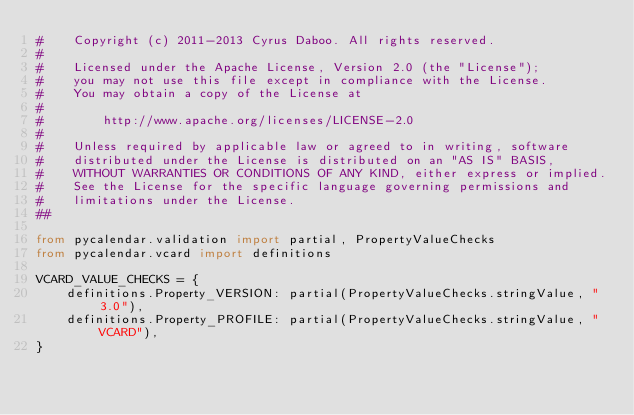Convert code to text. <code><loc_0><loc_0><loc_500><loc_500><_Python_>#    Copyright (c) 2011-2013 Cyrus Daboo. All rights reserved.
#
#    Licensed under the Apache License, Version 2.0 (the "License");
#    you may not use this file except in compliance with the License.
#    You may obtain a copy of the License at
#
#        http://www.apache.org/licenses/LICENSE-2.0
#
#    Unless required by applicable law or agreed to in writing, software
#    distributed under the License is distributed on an "AS IS" BASIS,
#    WITHOUT WARRANTIES OR CONDITIONS OF ANY KIND, either express or implied.
#    See the License for the specific language governing permissions and
#    limitations under the License.
##

from pycalendar.validation import partial, PropertyValueChecks
from pycalendar.vcard import definitions

VCARD_VALUE_CHECKS = {
    definitions.Property_VERSION: partial(PropertyValueChecks.stringValue, "3.0"),
    definitions.Property_PROFILE: partial(PropertyValueChecks.stringValue, "VCARD"),
}
</code> 